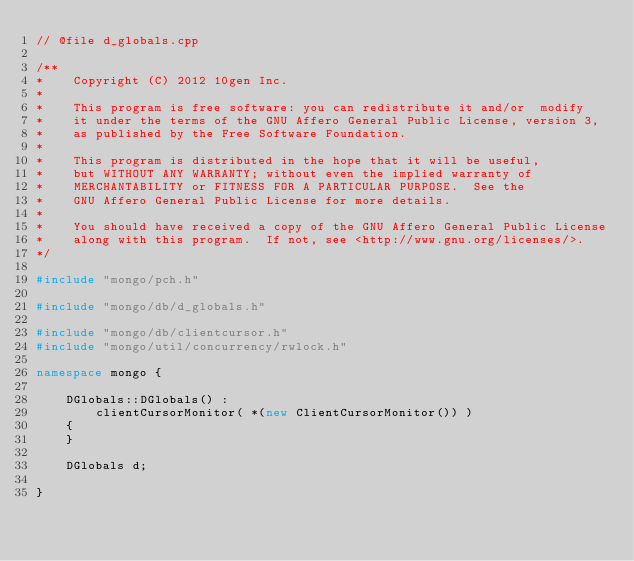<code> <loc_0><loc_0><loc_500><loc_500><_C++_>// @file d_globals.cpp

/**
*    Copyright (C) 2012 10gen Inc.
*
*    This program is free software: you can redistribute it and/or  modify
*    it under the terms of the GNU Affero General Public License, version 3,
*    as published by the Free Software Foundation.
*
*    This program is distributed in the hope that it will be useful,
*    but WITHOUT ANY WARRANTY; without even the implied warranty of
*    MERCHANTABILITY or FITNESS FOR A PARTICULAR PURPOSE.  See the
*    GNU Affero General Public License for more details.
*
*    You should have received a copy of the GNU Affero General Public License
*    along with this program.  If not, see <http://www.gnu.org/licenses/>.
*/

#include "mongo/pch.h"

#include "mongo/db/d_globals.h"

#include "mongo/db/clientcursor.h"
#include "mongo/util/concurrency/rwlock.h"

namespace mongo { 

    DGlobals::DGlobals() :
        clientCursorMonitor( *(new ClientCursorMonitor()) )
    {
    }

    DGlobals d;

}
</code> 